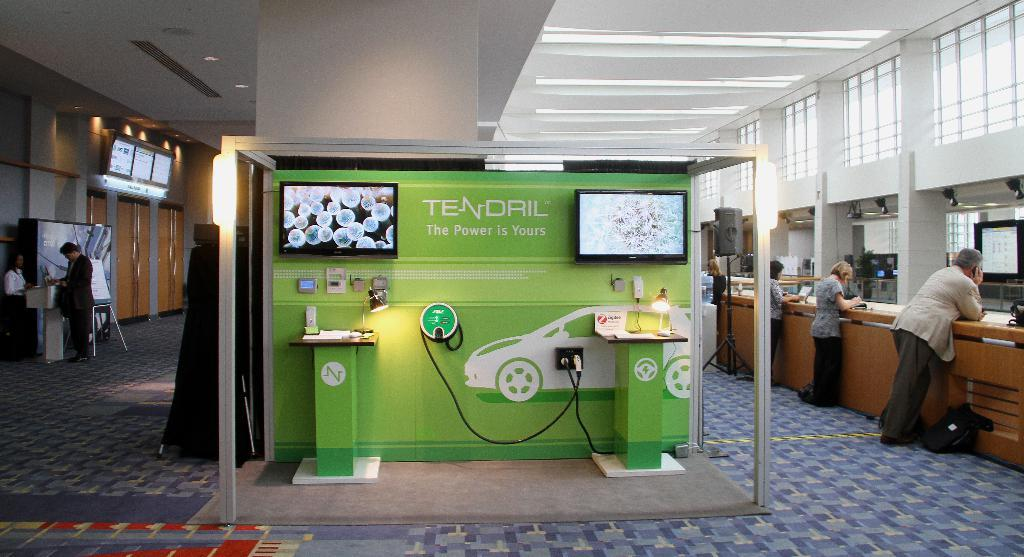What can be seen in the image? There are people standing in the image, wearing clothes and shoes. What objects are present in the image? There is a bag, a sound box, a stand, a floor, windows, a screen, a cable wire, a podium, and a poster in the image. What song is being sung by the people in the image? There is no indication of a song being sung in the image; the people are simply standing. What holiday is being celebrated in the image? There is no indication of a holiday being celebrated in the image. 